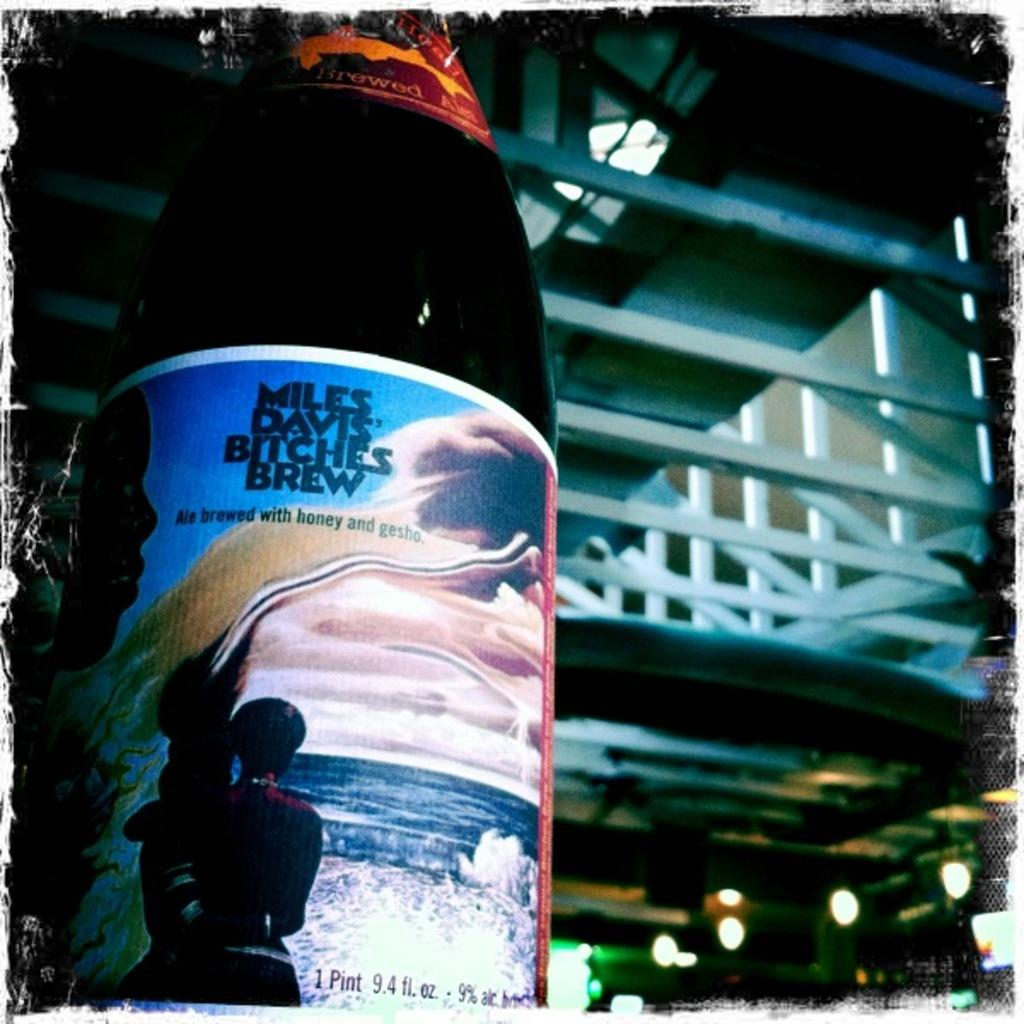Provide a one-sentence caption for the provided image. A bottle with Miles Davis Bitches Brew on the label with an seascape illustration of a person looking out towards sea. 